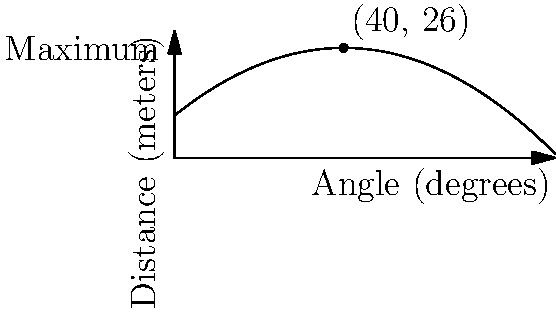Based on the polynomial graph representing the relationship between the angle of a corner kick and the distance the ball travels, what is the optimal angle for Brett to achieve maximum distance on his corner kicks? To find the optimal angle for maximum distance, we need to follow these steps:

1. Observe the graph: The graph shows a parabolic curve representing the relationship between the angle of the kick (x-axis) and the distance the ball travels (y-axis).

2. Identify the vertex: The vertex of the parabola represents the maximum point of the function. This point is clearly marked on the graph.

3. Read the x-coordinate: The x-coordinate of the vertex corresponds to the optimal angle for the kick.

4. Interpret the result: From the graph, we can see that the vertex is labeled as (40, 26). This means that at a 40-degree angle, the ball travels the maximum distance of 26 meters.

The polynomial function for this graph can be approximated as:

$$ f(x) = -0.01x^2 + 0.8x + 10 $$

Where $x$ is the angle in degrees and $f(x)$ is the distance in meters.

The vertex form of a quadratic function is $f(x) = -a(x-h)^2 + k$, where $(h,k)$ is the vertex. In this case, $h = 40$ represents the optimal angle.
Answer: 40 degrees 